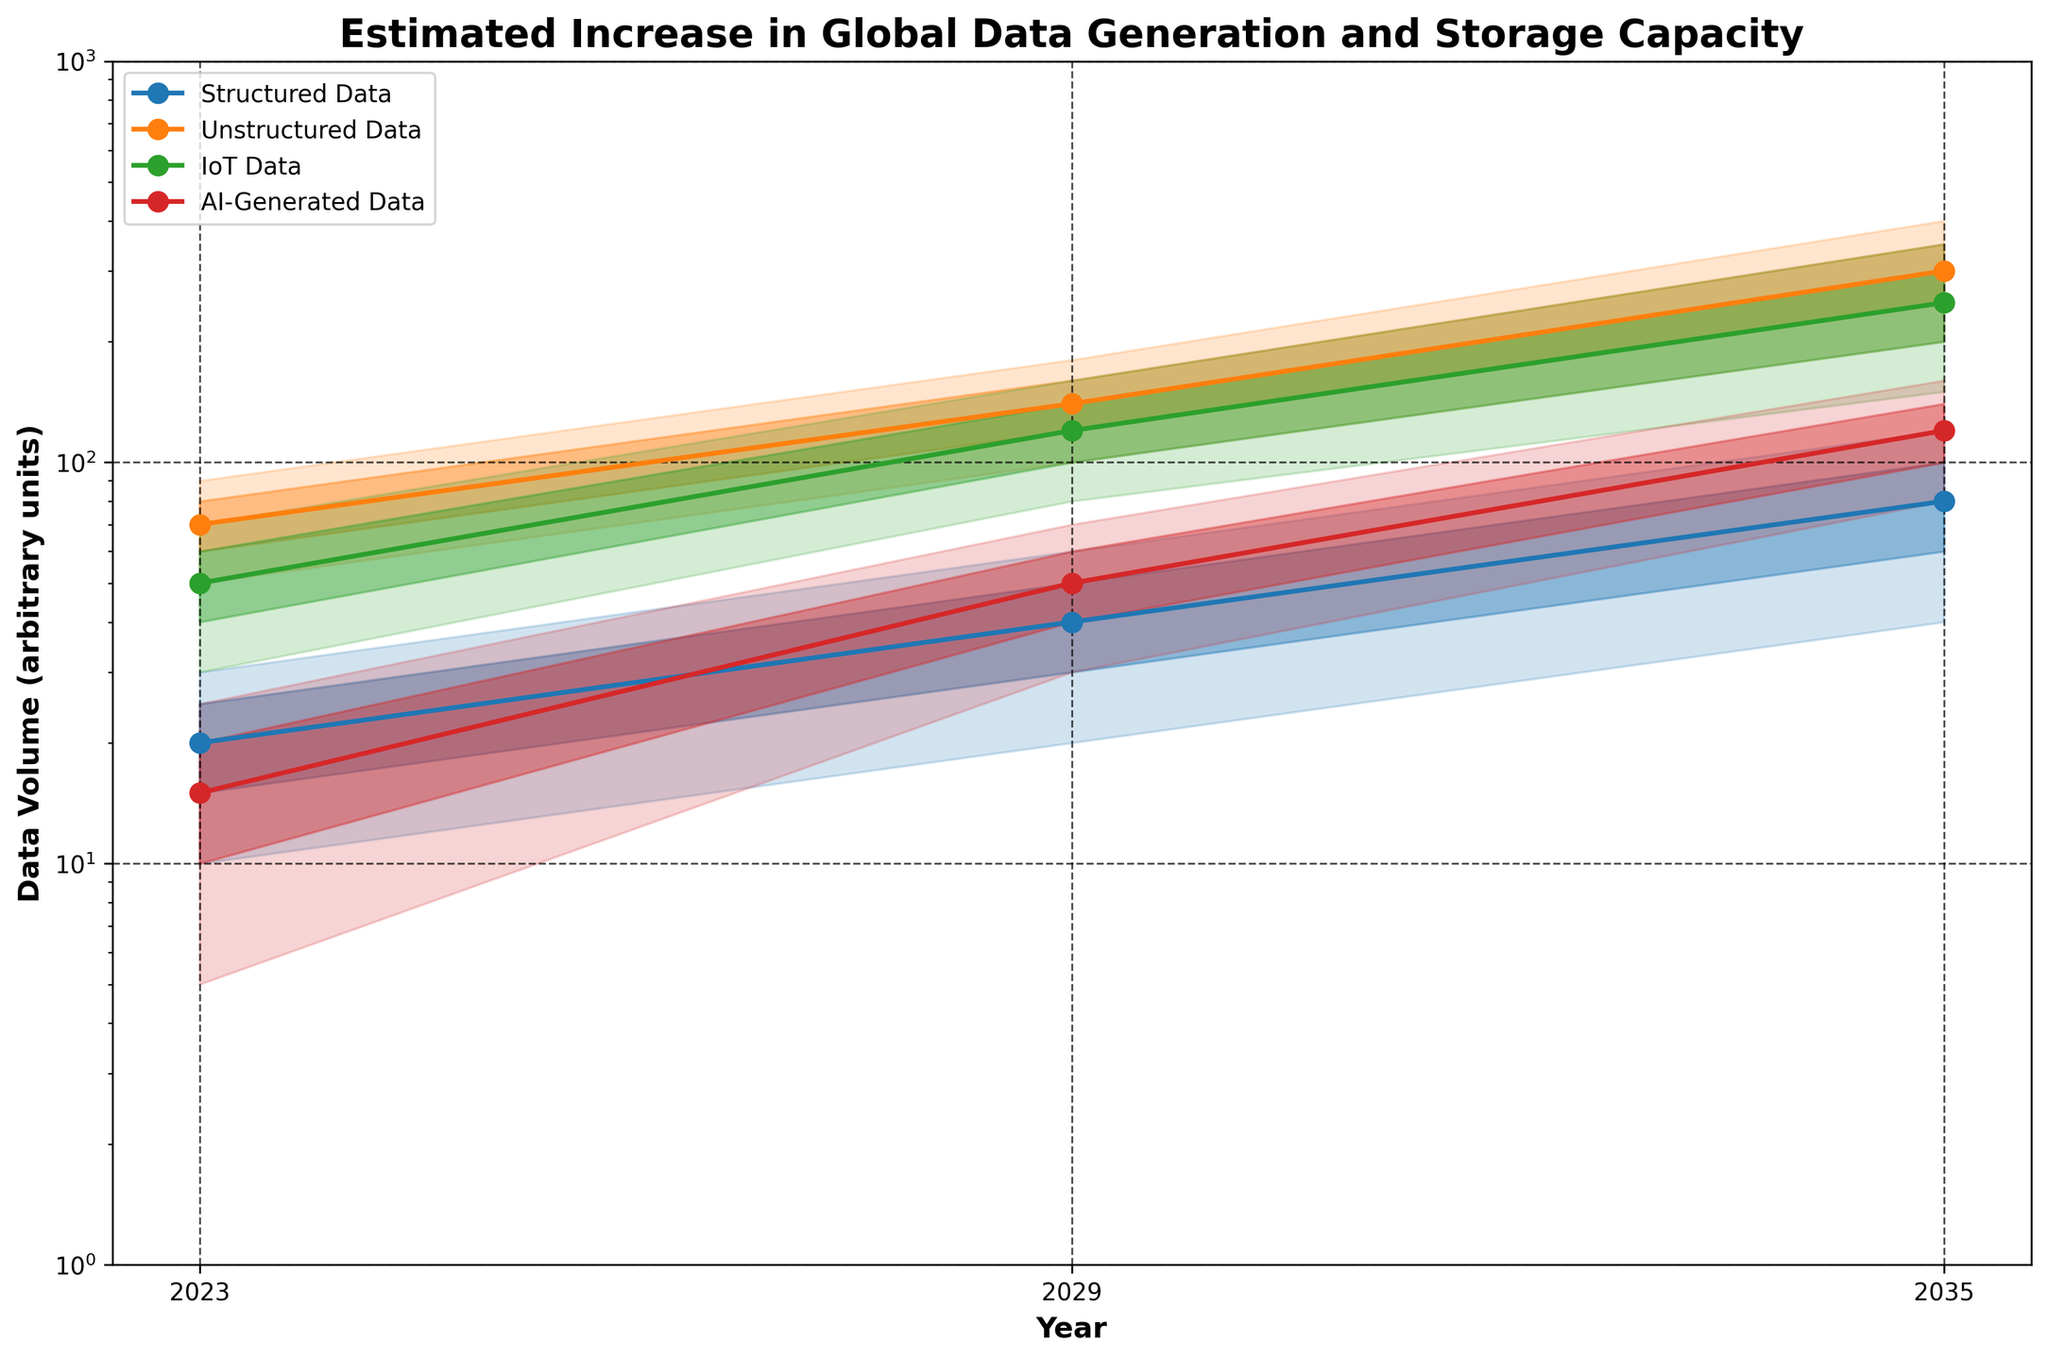What is the title of the chart? The title is the text at the top of the chart that gives a summary or name of what the chart is showing.
Answer: Estimated Increase in Global Data Generation and Storage Capacity What are the years displayed on the x-axis? The x-axis has labels indicating specific years for which data is shown in the chart.
Answer: 2023, 2029, 2035 Which data type has the highest median value in 2029? Look at the median values (middle line in each band) for each data type in 2029 and find the highest one.
Answer: Unstructured Data What is the range of AI-Generated Data in 2035? The range is the difference between the upper bound and lower bound values for AI-Generated Data in 2035.
Answer: 80 (Lower Bound) to 160 (Upper Bound) Which data type shows the fastest growth in median value from 2023 to 2035? Calculate the difference in median values for each data type between 2023 and 2035 and compare them.
Answer: Unstructured Data What is the lower-middle estimate of IoT Data in 2029? Look at the value at the lower-middle line (second line from the bottom) for IoT Data in 2029.
Answer: 100 How does the upper bound of Structured Data in 2023 compare to the lower bound of IoT Data in the same year? Compare the highest value of Structured Data's range with the lowest value of IoT Data's range in 2023.
Answer: Structured Data's upper bound (30) is less than IoT Data's lower bound (30) What trends can be observed in the median values of AI-Generated Data across the years? Track the median values (middle line in each band) for AI-Generated Data from 2023 to 2035 to observe trends.
Answer: Increasing from 15 to 120 Which data type occupies the largest area under the curves in 2035? The largest area under the curves (range between lower and upper bounds) signifies the most substantial data capacity.
Answer: Unstructured Data What is the difference between the upper-middle estimate and the lower-middle estimate of Unstructured Data in 2029? Subtract the lower-middle estimate from the upper-middle estimate for Unstructured Data in 2029.
Answer: 160 - 120 = 40 